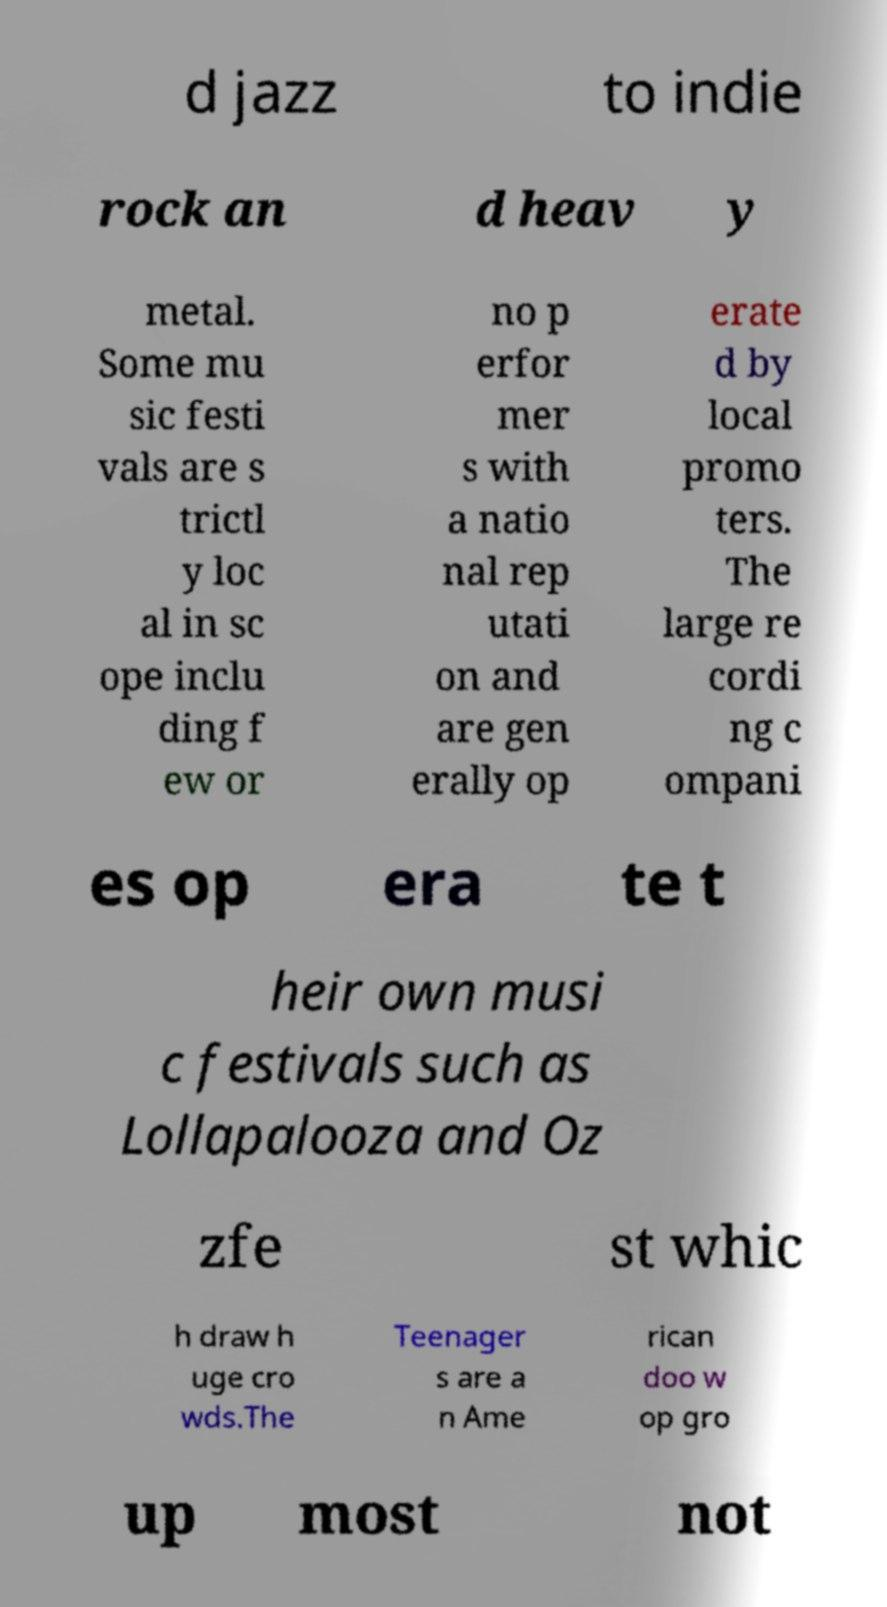Please read and relay the text visible in this image. What does it say? d jazz to indie rock an d heav y metal. Some mu sic festi vals are s trictl y loc al in sc ope inclu ding f ew or no p erfor mer s with a natio nal rep utati on and are gen erally op erate d by local promo ters. The large re cordi ng c ompani es op era te t heir own musi c festivals such as Lollapalooza and Oz zfe st whic h draw h uge cro wds.The Teenager s are a n Ame rican doo w op gro up most not 